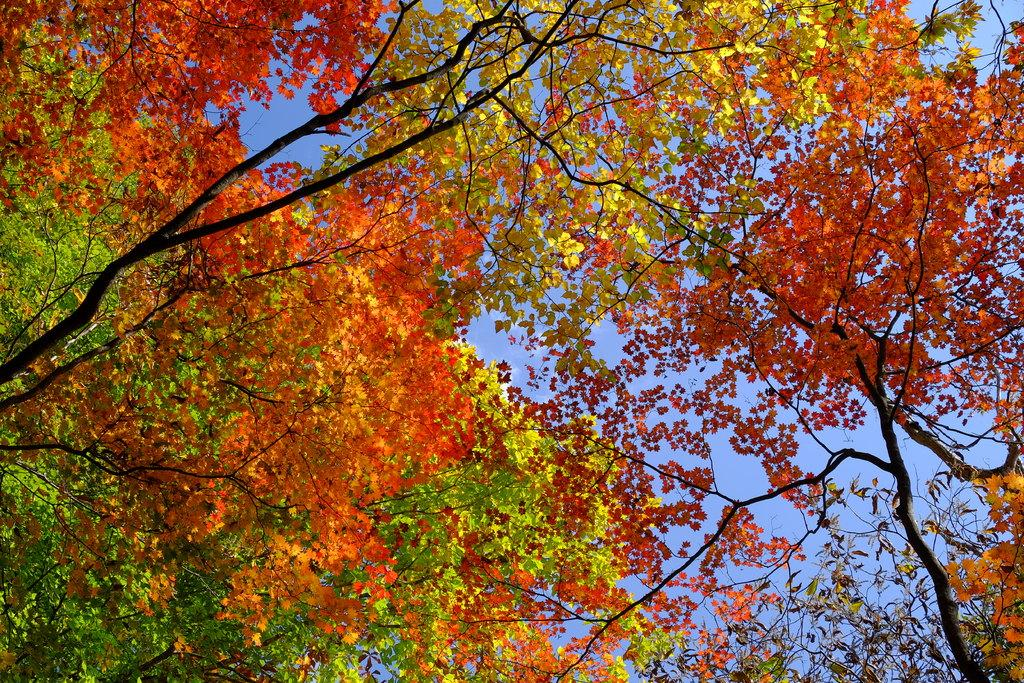What type of vegetation can be seen in the image? There are trees in the image. What part of the natural environment is visible in the image? The sky is visible in the background of the image. What type of frame is used to display the dinner in the image? There is no dinner present in the image, and therefore no frame is used to display it. 